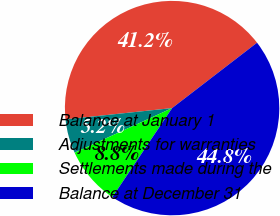Convert chart. <chart><loc_0><loc_0><loc_500><loc_500><pie_chart><fcel>Balance at January 1<fcel>Adjustments for warranties<fcel>Settlements made during the<fcel>Balance at December 31<nl><fcel>41.24%<fcel>5.15%<fcel>8.76%<fcel>44.85%<nl></chart> 